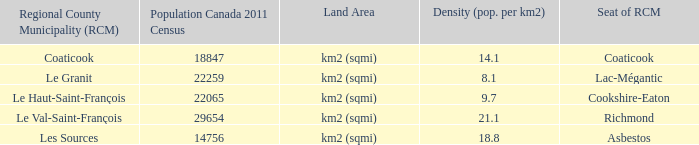1? Km2 (sqmi). Would you mind parsing the complete table? {'header': ['Regional County Municipality (RCM)', 'Population Canada 2011 Census', 'Land Area', 'Density (pop. per km2)', 'Seat of RCM'], 'rows': [['Coaticook', '18847', 'km2 (sqmi)', '14.1', 'Coaticook'], ['Le Granit', '22259', 'km2 (sqmi)', '8.1', 'Lac-Mégantic'], ['Le Haut-Saint-François', '22065', 'km2 (sqmi)', '9.7', 'Cookshire-Eaton'], ['Le Val-Saint-François', '29654', 'km2 (sqmi)', '21.1', 'Richmond'], ['Les Sources', '14756', 'km2 (sqmi)', '18.8', 'Asbestos']]} 